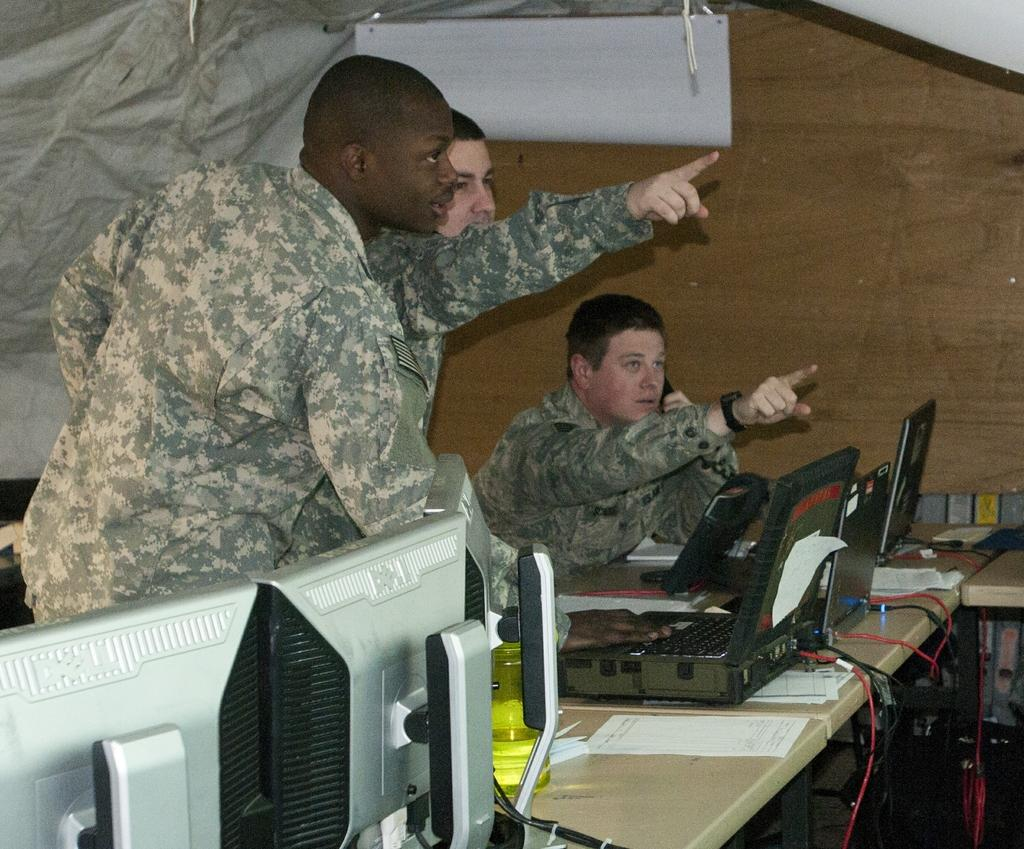How many men are in the image? There are two men standing in the image, and one man sitting in the image. What objects are present in the image that are used for displaying information? There are monitors present in the image. What type of items can be seen on the table in the image? There are papers visible in the image, and a laptop is present on the table. Where is the mom in the image? There is no mom present in the image. What type of cup is being used by the men in the image? There is no cup visible in the image. 